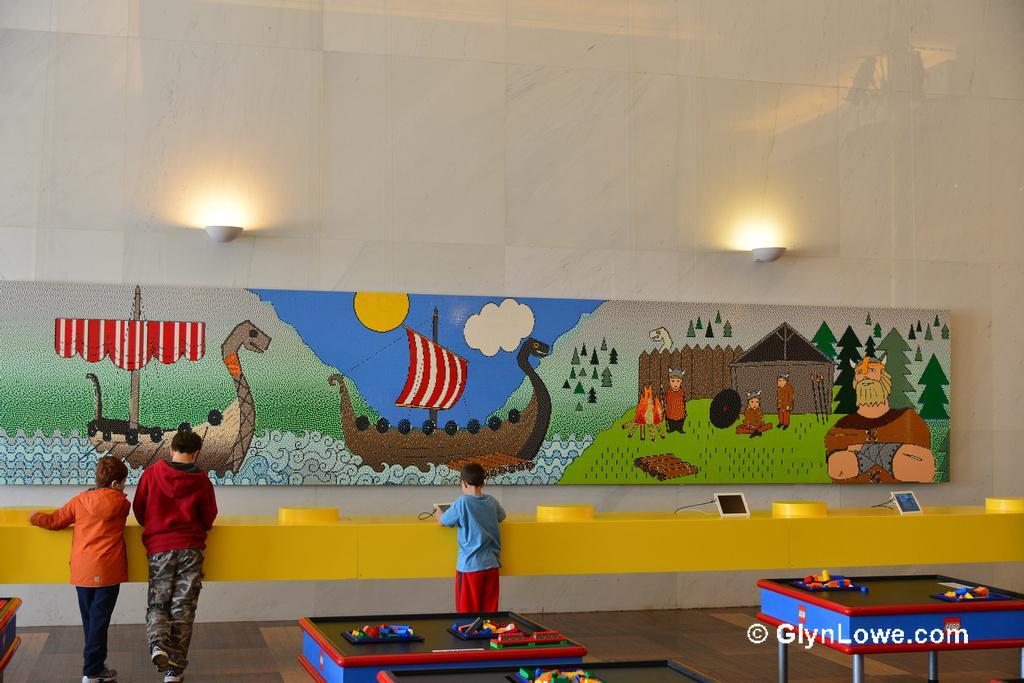Could you give a brief overview of what you see in this image? In this Image I see 3 boys who are standing and there are few tables over here. In the background I see few electronic devices, an art over here and lights on the wall. 